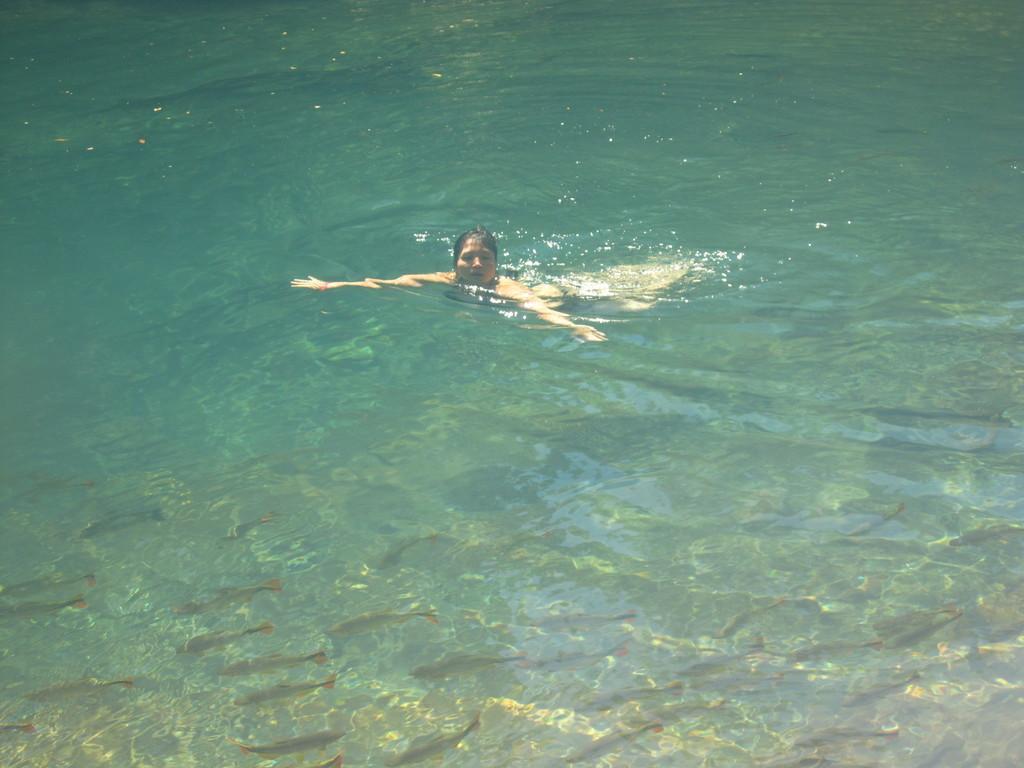Can you describe this image briefly? In this picture I can see a woman swimming in the water. 